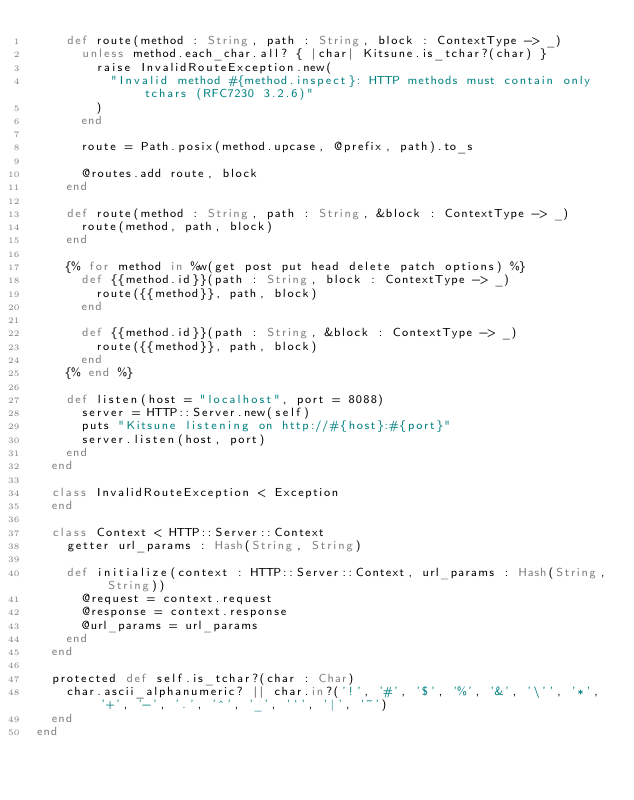Convert code to text. <code><loc_0><loc_0><loc_500><loc_500><_Crystal_>    def route(method : String, path : String, block : ContextType -> _)
      unless method.each_char.all? { |char| Kitsune.is_tchar?(char) }
        raise InvalidRouteException.new(
          "Invalid method #{method.inspect}: HTTP methods must contain only tchars (RFC7230 3.2.6)"
        )
      end

      route = Path.posix(method.upcase, @prefix, path).to_s

      @routes.add route, block
    end

    def route(method : String, path : String, &block : ContextType -> _)
      route(method, path, block)
    end

    {% for method in %w(get post put head delete patch options) %}
      def {{method.id}}(path : String, block : ContextType -> _)
        route({{method}}, path, block)
      end

      def {{method.id}}(path : String, &block : ContextType -> _)
        route({{method}}, path, block)
      end
    {% end %}

    def listen(host = "localhost", port = 8088)
      server = HTTP::Server.new(self)
      puts "Kitsune listening on http://#{host}:#{port}"
      server.listen(host, port)
    end
  end

  class InvalidRouteException < Exception
  end

  class Context < HTTP::Server::Context
    getter url_params : Hash(String, String)

    def initialize(context : HTTP::Server::Context, url_params : Hash(String, String))
      @request = context.request
      @response = context.response
      @url_params = url_params
    end
  end

  protected def self.is_tchar?(char : Char)
    char.ascii_alphanumeric? || char.in?('!', '#', '$', '%', '&', '\'', '*', '+', '-', '.', '^', '_', '`', '|', '~')
  end
end
</code> 